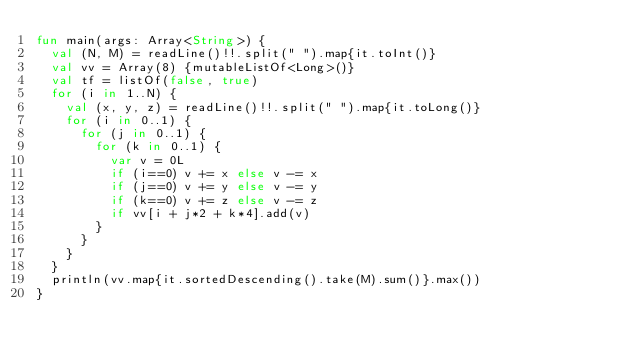Convert code to text. <code><loc_0><loc_0><loc_500><loc_500><_Kotlin_>fun main(args: Array<String>) {
  val (N, M) = readLine()!!.split(" ").map{it.toInt()}
  val vv = Array(8) {mutableListOf<Long>()}
  val tf = listOf(false, true)
  for (i in 1..N) {
    val (x, y, z) = readLine()!!.split(" ").map{it.toLong()}
    for (i in 0..1) {
      for (j in 0..1) {
        for (k in 0..1) {
          var v = 0L
          if (i==0) v += x else v -= x
          if (j==0) v += y else v -= y
          if (k==0) v += z else v -= z
          if vv[i + j*2 + k*4].add(v)
        }
      }
    }
  }
  println(vv.map{it.sortedDescending().take(M).sum()}.max())
}</code> 